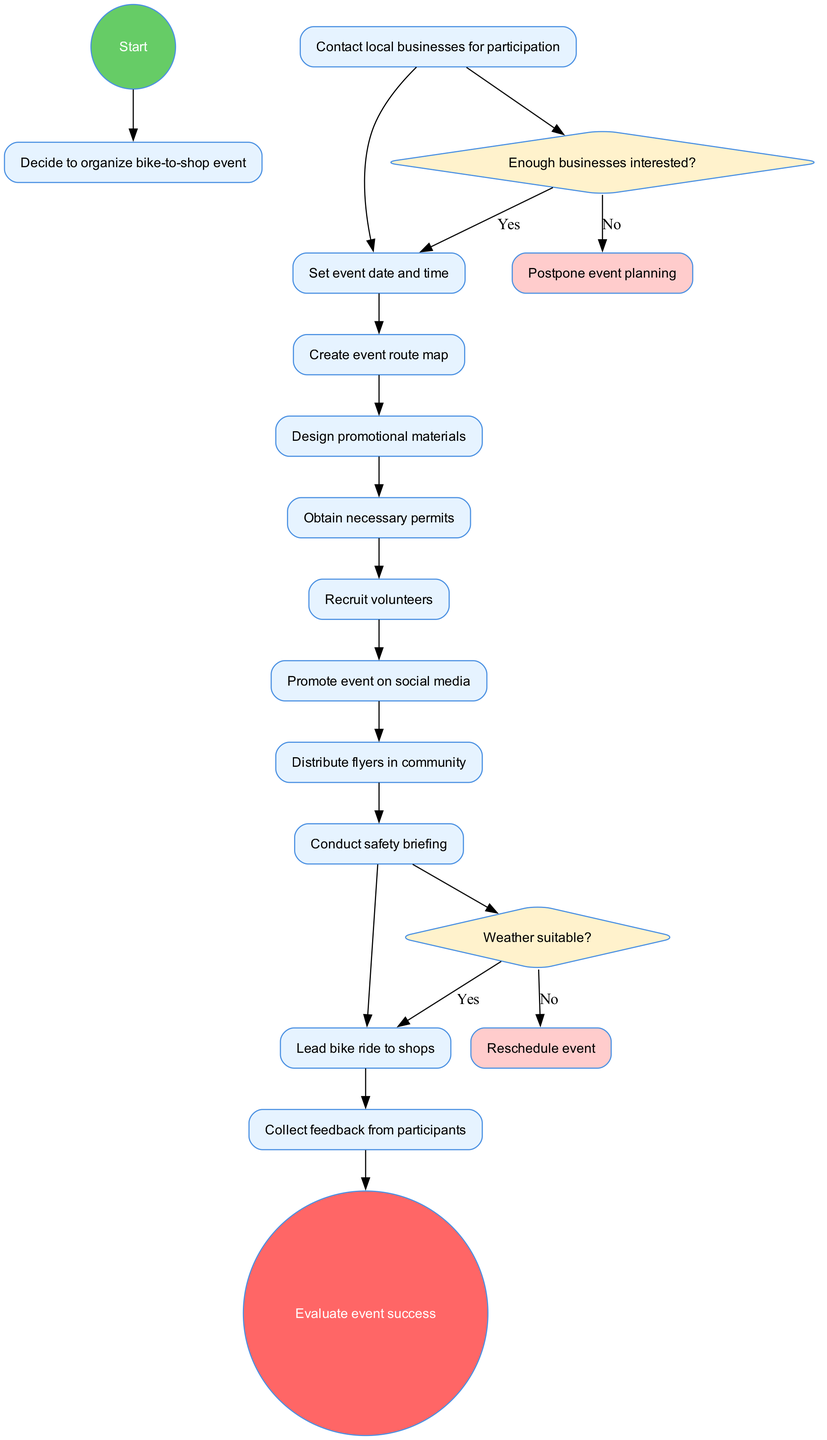What is the starting node of the diagram? The starting node is explicitly labeled in the diagram as "Decide to organize bike-to-shop event."
Answer: Decide to organize bike-to-shop event How many activities are listed in the diagram? The list of activities can be counted directly from the diagram, which shows 11 different activities.
Answer: 11 What is the first decision condition in the diagram? The first decision node indicates the condition "Enough businesses interested?" which is the starting point of the decision-making process.
Answer: Enough businesses interested? What happens if the weather is not suitable? The diagram illustrates that if the weather is not suitable, the process leads to the "Reschedule event" node, which shows the action taken.
Answer: Reschedule event What is the final node in the diagram? The final node is clearly indicated at the end of the diagram as "Evaluate event success," representing the conclusion of the process.
Answer: Evaluate event success What is the relationship between the decision of businesses’ interest and the event date? The diagram shows that if there are enough businesses interested, it proceeds to "Set event date and time." If not, it leads to "Postpone event planning," demonstrating a conditional relationship.
Answer: Set event date and time What is the role of volunteers in the event organization process? The diagram specifies that recruiting volunteers is one of the activities, indicating that they play a critical role in the event.
Answer: Recruit volunteers How many decision nodes are present in the diagram? The diagram outlines two decision nodes, each changing the course of actions based on specific conditions, highlighting the decision points in the process.
Answer: 2 What is the immediate action after creating promotional materials? Following the activity of designing promotional materials, the next action is promoting the event on social media according to the flow of activities in the diagram.
Answer: Promote event on social media 